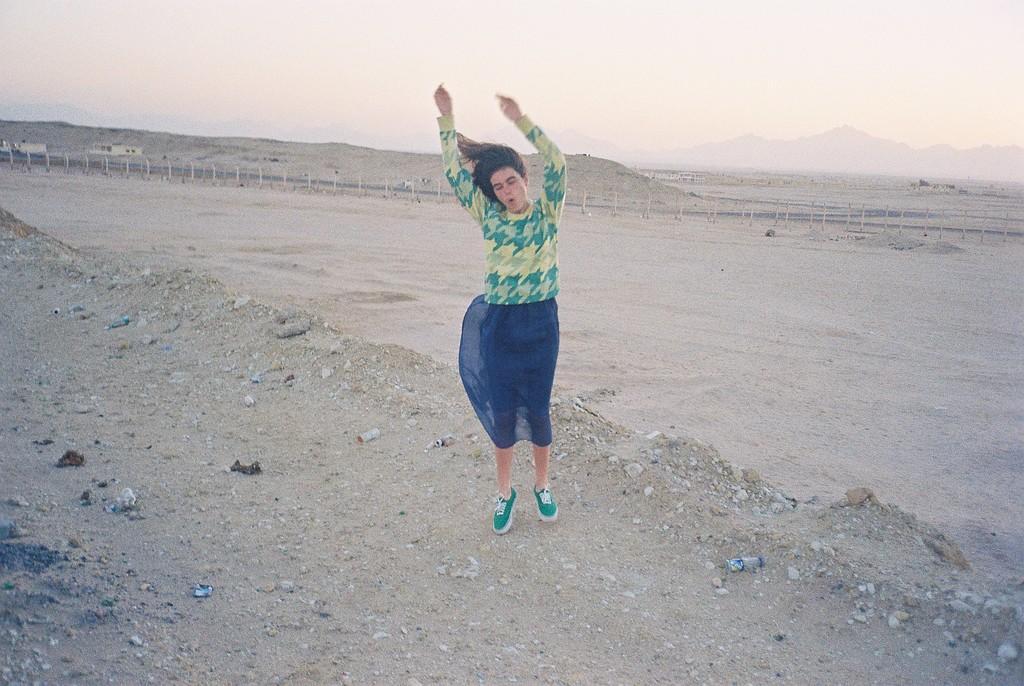In one or two sentences, can you explain what this image depicts? Background portion of the picture is blurred. In this picture we can see the sky, poles and hills. We can see a woman is jumping. 